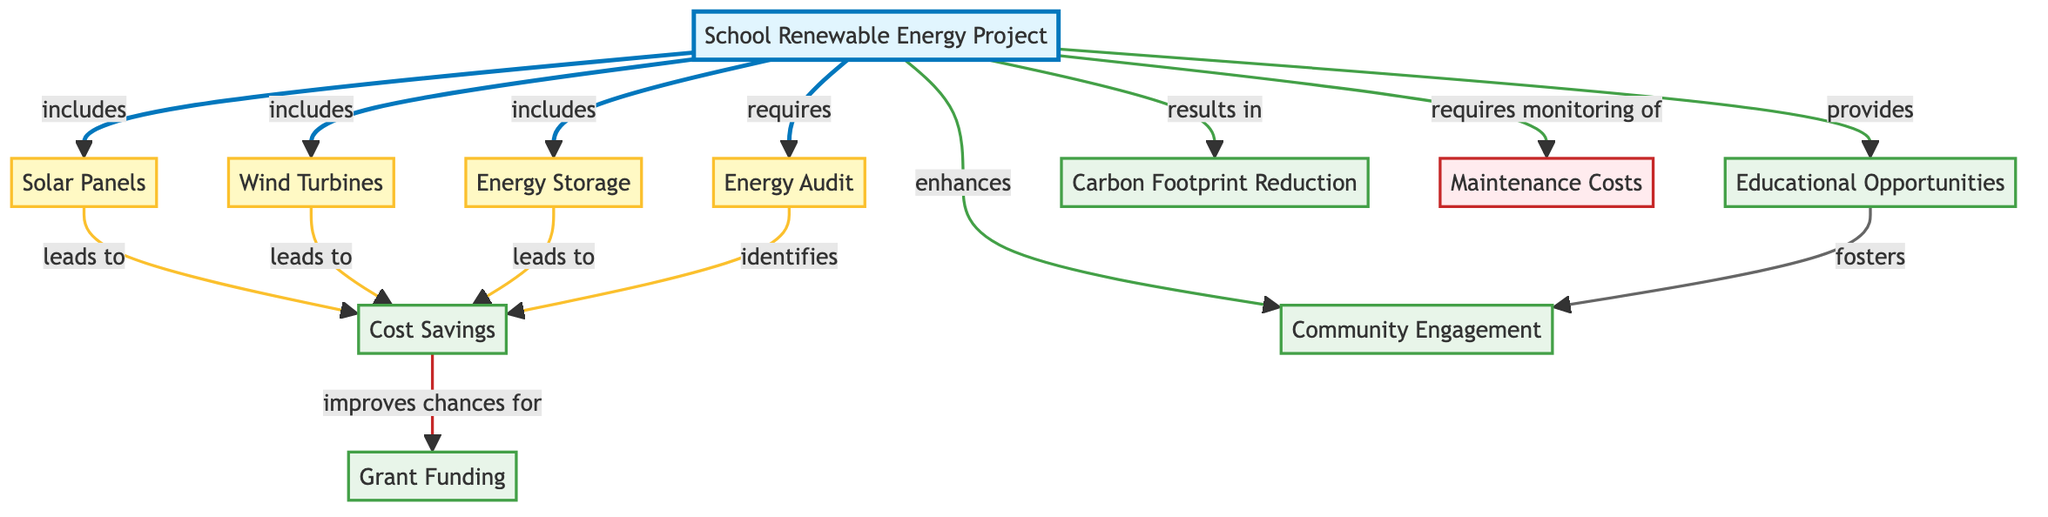What is the total number of nodes in the diagram? The diagram lists 11 distinct nodes representing various components and aspects of the school renewable energy project. Count each node in the provided data to confirm the total.
Answer: 11 What nodes lead to cost savings? The nodes that lead to cost savings are Solar Panels, Wind Turbines, and Energy Storage, as indicated by the edges connecting them to the Cost Savings node.
Answer: Solar Panels, Wind Turbines, Energy Storage Which node requires monitoring of maintenance costs? The School Renewable Energy Project node indicates that monitoring of Maintenance Costs is required, as shown by the directed edge leading from it to the Maintenance Costs node.
Answer: School Renewable Energy Project How many components are included in the School Renewable Energy Project? The diagram indicates that the School Renewable Energy Project includes three components: Solar Panels, Wind Turbines, and Energy Storage. Each of these is denoted by an edge leading to the project node.
Answer: 3 What provides educational opportunities? The School Renewable Energy Project provides educational opportunities, as shown by the edge that connects the project to the Educational Opportunities node.
Answer: School Renewable Energy Project Which node is enhanced by community engagement? The Community Engagement node is enhanced by the Educational Opportunities node, indicated by the edge connecting them, which demonstrates the fostering relationship between them.
Answer: Educational Opportunities What improves chances for grant funding? The Cost Savings node improves chances for grant funding, as denoted by the edge leading from Cost Savings to Grant Funding in the diagram.
Answer: Cost Savings What is the relationship between the School Renewable Energy Project and carbon footprint reduction? The relationship is that the School Renewable Energy Project results in carbon footprint reduction, as explicitly stated in the directed edge connecting these two nodes.
Answer: results in Which components lead to cost savings? The components that lead to cost savings are identified in the diagram: Solar Panels, Wind Turbines, and Energy Storage, since each one has directed edges leading to the Cost Savings outcome.
Answer: Solar Panels, Wind Turbines, Energy Storage 